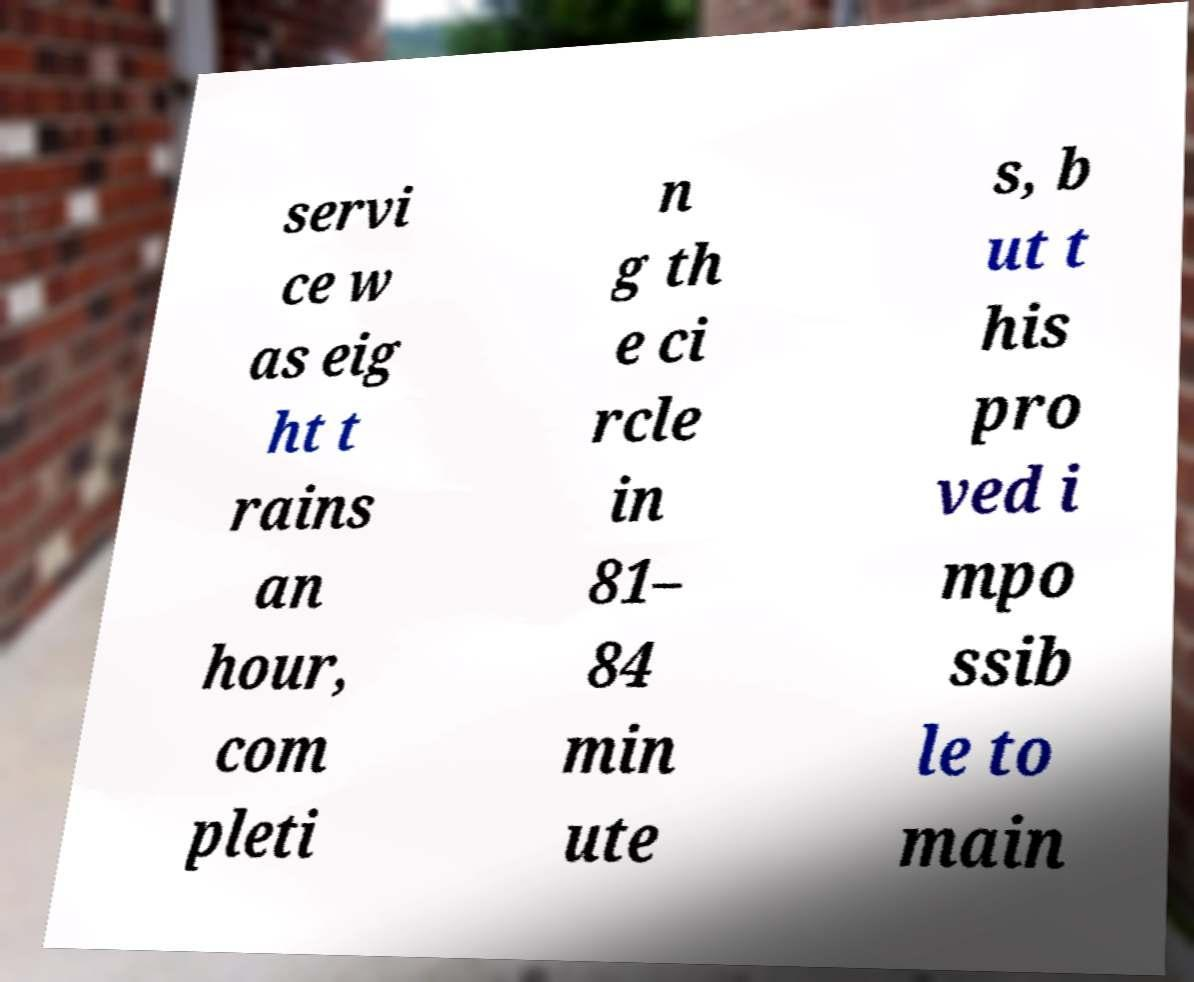What messages or text are displayed in this image? I need them in a readable, typed format. servi ce w as eig ht t rains an hour, com pleti n g th e ci rcle in 81– 84 min ute s, b ut t his pro ved i mpo ssib le to main 